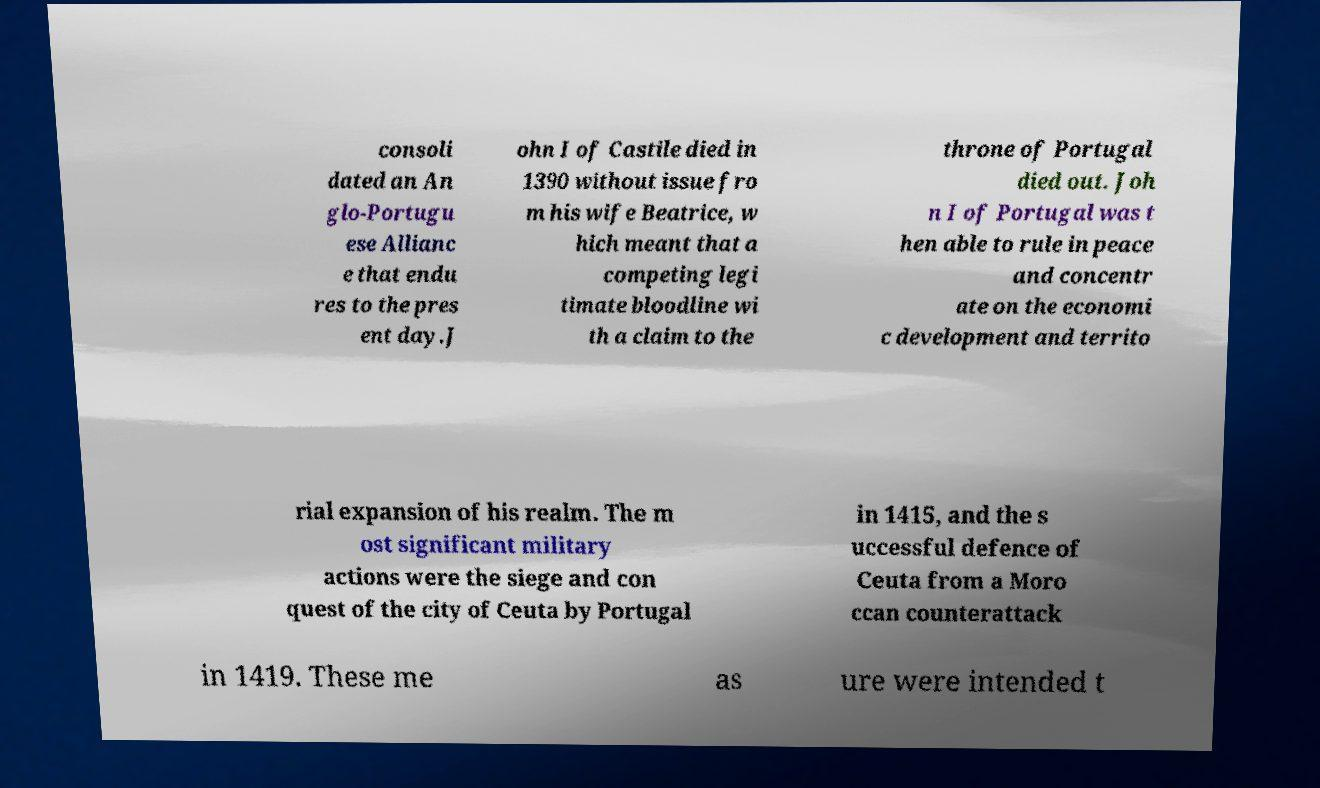For documentation purposes, I need the text within this image transcribed. Could you provide that? consoli dated an An glo-Portugu ese Allianc e that endu res to the pres ent day.J ohn I of Castile died in 1390 without issue fro m his wife Beatrice, w hich meant that a competing legi timate bloodline wi th a claim to the throne of Portugal died out. Joh n I of Portugal was t hen able to rule in peace and concentr ate on the economi c development and territo rial expansion of his realm. The m ost significant military actions were the siege and con quest of the city of Ceuta by Portugal in 1415, and the s uccessful defence of Ceuta from a Moro ccan counterattack in 1419. These me as ure were intended t 